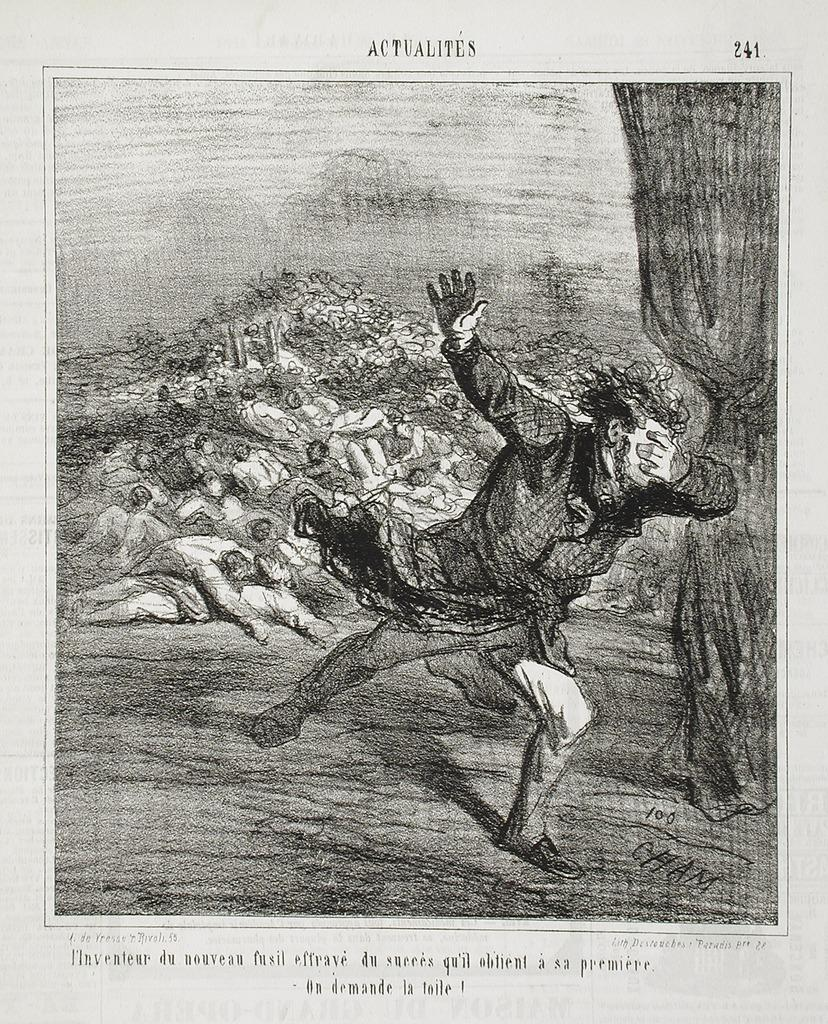What is the main subject of the printed paper in the image? There is a picture of a man running in the image. Where is the text located on the printed paper? There is text at the top and bottom of the image. What type of activity is the man in the picture engaged in? The man in the picture is running. What type of wheel is featured in the image? There is no wheel present in the image. Is there a party happening in the image? There is no indication of a party in the image; it features a picture of a man running and text on a printed paper. 